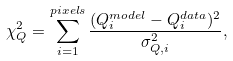<formula> <loc_0><loc_0><loc_500><loc_500>\chi ^ { 2 } _ { Q } = \sum _ { i = 1 } ^ { p i x e l s } \frac { ( Q ^ { m o d e l } _ { i } - Q ^ { d a t a } _ { i } ) ^ { 2 } } { \sigma ^ { 2 } _ { Q , i } } ,</formula> 